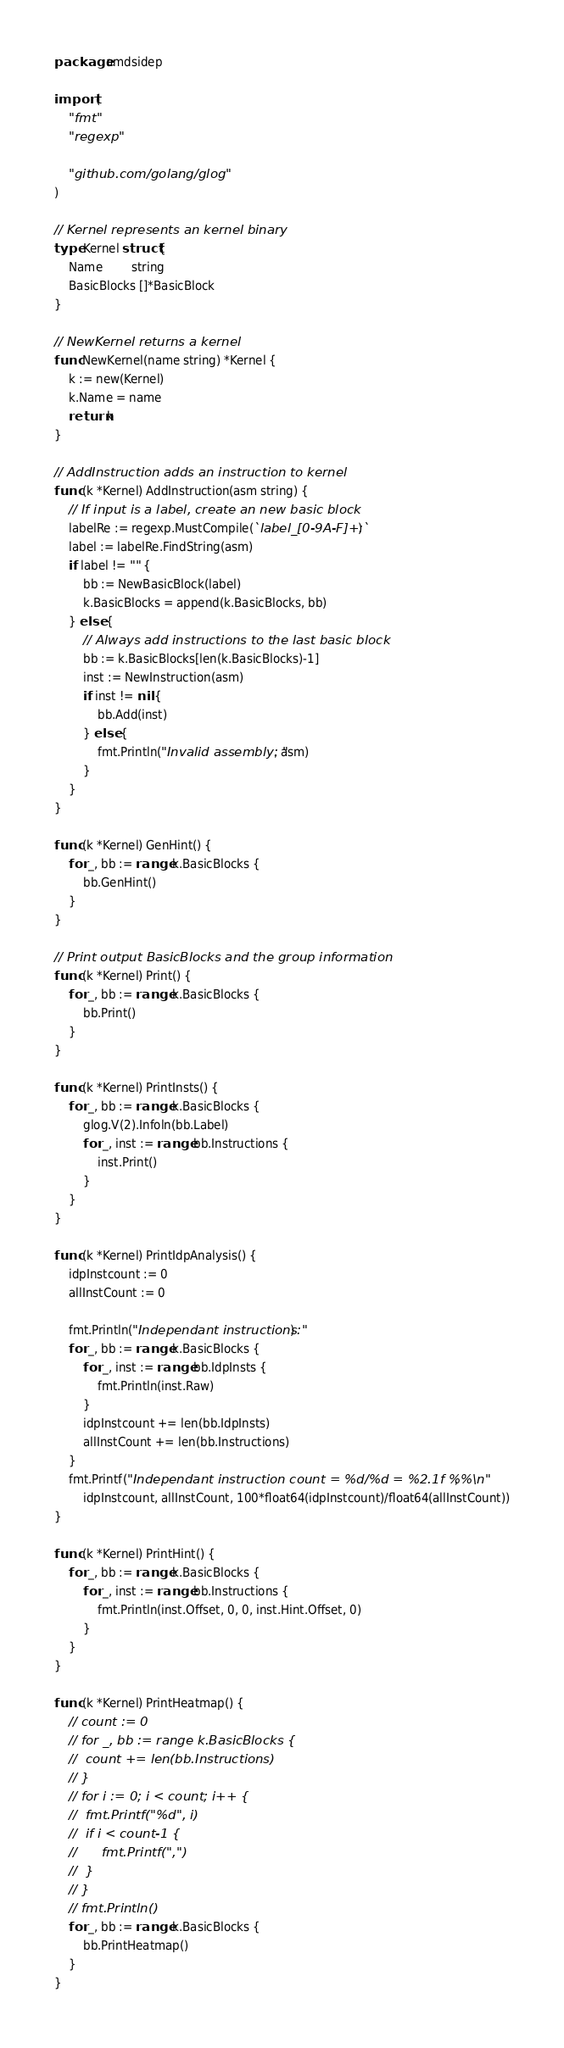Convert code to text. <code><loc_0><loc_0><loc_500><loc_500><_Go_>package amdsidep

import (
	"fmt"
	"regexp"

	"github.com/golang/glog"
)

// Kernel represents an kernel binary
type Kernel struct {
	Name        string
	BasicBlocks []*BasicBlock
}

// NewKernel returns a kernel
func NewKernel(name string) *Kernel {
	k := new(Kernel)
	k.Name = name
	return k
}

// AddInstruction adds an instruction to kernel
func (k *Kernel) AddInstruction(asm string) {
	// If input is a label, create an new basic block
	labelRe := regexp.MustCompile(`label_[0-9A-F]+:`)
	label := labelRe.FindString(asm)
	if label != "" {
		bb := NewBasicBlock(label)
		k.BasicBlocks = append(k.BasicBlocks, bb)
	} else {
		// Always add instructions to the last basic block
		bb := k.BasicBlocks[len(k.BasicBlocks)-1]
		inst := NewInstruction(asm)
		if inst != nil {
			bb.Add(inst)
		} else {
			fmt.Println("Invalid assembly: ", asm)
		}
	}
}

func (k *Kernel) GenHint() {
	for _, bb := range k.BasicBlocks {
		bb.GenHint()
	}
}

// Print output BasicBlocks and the group information
func (k *Kernel) Print() {
	for _, bb := range k.BasicBlocks {
		bb.Print()
	}
}

func (k *Kernel) PrintInsts() {
	for _, bb := range k.BasicBlocks {
		glog.V(2).Infoln(bb.Label)
		for _, inst := range bb.Instructions {
			inst.Print()
		}
	}
}

func (k *Kernel) PrintIdpAnalysis() {
	idpInstcount := 0
	allInstCount := 0

	fmt.Println("Independant instructions:")
	for _, bb := range k.BasicBlocks {
		for _, inst := range bb.IdpInsts {
			fmt.Println(inst.Raw)
		}
		idpInstcount += len(bb.IdpInsts)
		allInstCount += len(bb.Instructions)
	}
	fmt.Printf("Independant instruction count = %d/%d = %2.1f %%\n",
		idpInstcount, allInstCount, 100*float64(idpInstcount)/float64(allInstCount))
}

func (k *Kernel) PrintHint() {
	for _, bb := range k.BasicBlocks {
		for _, inst := range bb.Instructions {
			fmt.Println(inst.Offset, 0, 0, inst.Hint.Offset, 0)
		}
	}
}

func (k *Kernel) PrintHeatmap() {
	// count := 0
	// for _, bb := range k.BasicBlocks {
	// 	count += len(bb.Instructions)
	// }
	// for i := 0; i < count; i++ {
	// 	fmt.Printf("%d", i)
	// 	if i < count-1 {
	// 		fmt.Printf(",")
	// 	}
	// }
	// fmt.Println()
	for _, bb := range k.BasicBlocks {
		bb.PrintHeatmap()
	}
}
</code> 